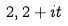<formula> <loc_0><loc_0><loc_500><loc_500>2 , 2 + i t</formula> 